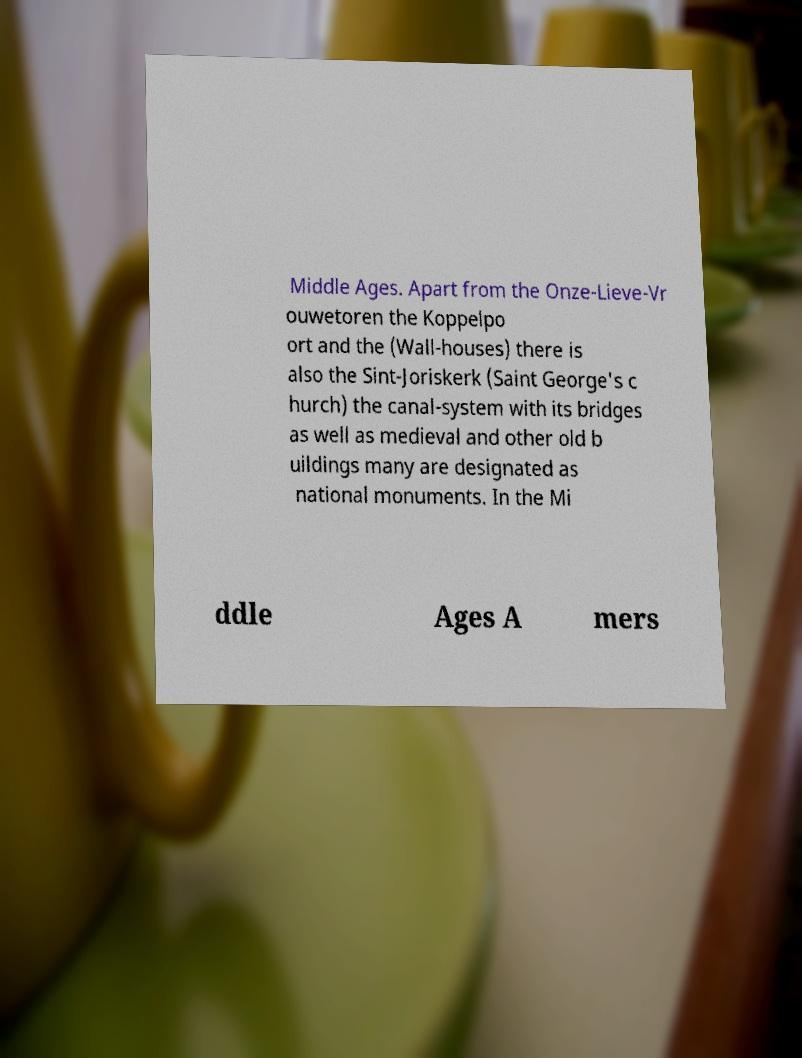There's text embedded in this image that I need extracted. Can you transcribe it verbatim? Middle Ages. Apart from the Onze-Lieve-Vr ouwetoren the Koppelpo ort and the (Wall-houses) there is also the Sint-Joriskerk (Saint George's c hurch) the canal-system with its bridges as well as medieval and other old b uildings many are designated as national monuments. In the Mi ddle Ages A mers 